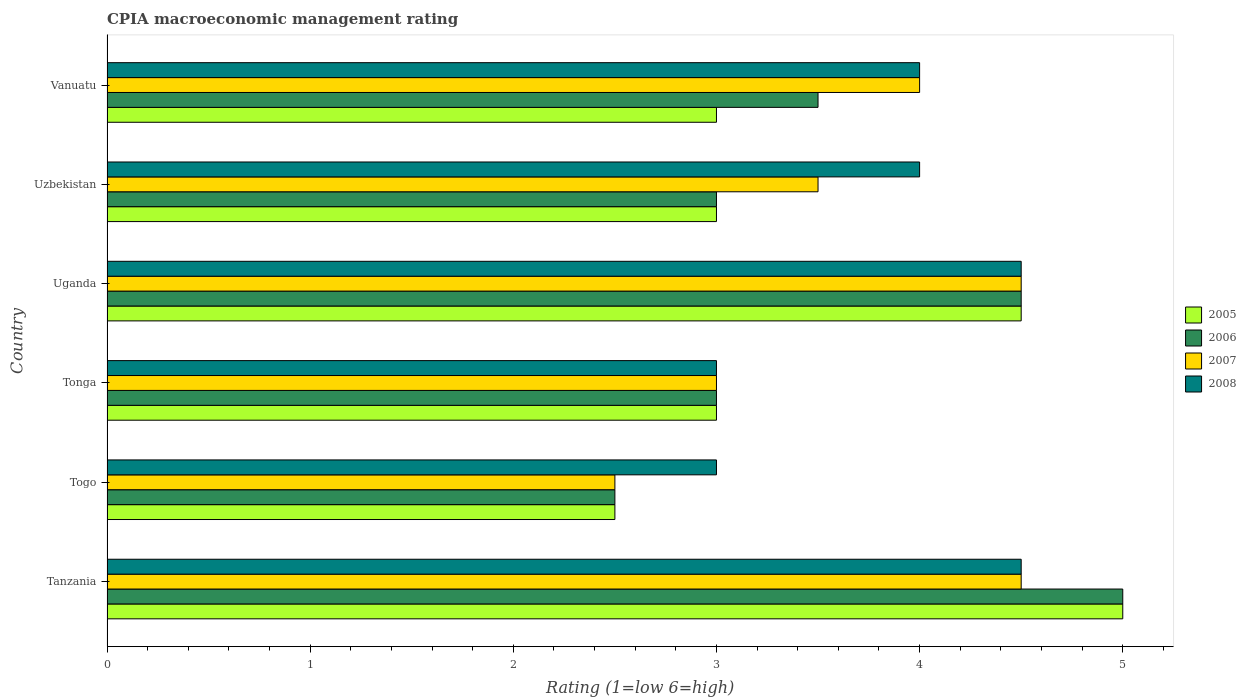How many different coloured bars are there?
Make the answer very short. 4. How many groups of bars are there?
Your response must be concise. 6. Are the number of bars per tick equal to the number of legend labels?
Offer a very short reply. Yes. How many bars are there on the 5th tick from the bottom?
Offer a very short reply. 4. What is the label of the 3rd group of bars from the top?
Ensure brevity in your answer.  Uganda. In how many cases, is the number of bars for a given country not equal to the number of legend labels?
Offer a very short reply. 0. What is the CPIA rating in 2005 in Togo?
Provide a short and direct response. 2.5. Across all countries, what is the maximum CPIA rating in 2008?
Your answer should be compact. 4.5. In which country was the CPIA rating in 2007 maximum?
Make the answer very short. Tanzania. In which country was the CPIA rating in 2008 minimum?
Make the answer very short. Togo. What is the total CPIA rating in 2008 in the graph?
Provide a succinct answer. 23. What is the difference between the CPIA rating in 2005 in Tanzania and the CPIA rating in 2006 in Tonga?
Your answer should be very brief. 2. What is the average CPIA rating in 2008 per country?
Provide a succinct answer. 3.83. What is the difference between the CPIA rating in 2007 and CPIA rating in 2006 in Uzbekistan?
Provide a succinct answer. 0.5. In how many countries, is the CPIA rating in 2007 greater than 0.4 ?
Give a very brief answer. 6. What is the ratio of the CPIA rating in 2005 in Uganda to that in Uzbekistan?
Your answer should be compact. 1.5. Is the difference between the CPIA rating in 2007 in Togo and Vanuatu greater than the difference between the CPIA rating in 2006 in Togo and Vanuatu?
Your response must be concise. No. What is the difference between the highest and the second highest CPIA rating in 2005?
Ensure brevity in your answer.  0.5. In how many countries, is the CPIA rating in 2008 greater than the average CPIA rating in 2008 taken over all countries?
Offer a very short reply. 4. Is it the case that in every country, the sum of the CPIA rating in 2007 and CPIA rating in 2008 is greater than the sum of CPIA rating in 2005 and CPIA rating in 2006?
Your response must be concise. No. What does the 4th bar from the bottom in Tanzania represents?
Your answer should be very brief. 2008. Is it the case that in every country, the sum of the CPIA rating in 2005 and CPIA rating in 2006 is greater than the CPIA rating in 2007?
Your answer should be compact. Yes. What is the difference between two consecutive major ticks on the X-axis?
Your answer should be very brief. 1. Are the values on the major ticks of X-axis written in scientific E-notation?
Give a very brief answer. No. Does the graph contain any zero values?
Keep it short and to the point. No. Does the graph contain grids?
Ensure brevity in your answer.  No. What is the title of the graph?
Provide a succinct answer. CPIA macroeconomic management rating. Does "2007" appear as one of the legend labels in the graph?
Ensure brevity in your answer.  Yes. What is the label or title of the Y-axis?
Provide a succinct answer. Country. What is the Rating (1=low 6=high) of 2005 in Togo?
Offer a very short reply. 2.5. What is the Rating (1=low 6=high) of 2006 in Togo?
Your answer should be very brief. 2.5. What is the Rating (1=low 6=high) of 2007 in Togo?
Give a very brief answer. 2.5. What is the Rating (1=low 6=high) of 2008 in Togo?
Keep it short and to the point. 3. What is the Rating (1=low 6=high) of 2005 in Tonga?
Offer a terse response. 3. What is the Rating (1=low 6=high) of 2006 in Tonga?
Give a very brief answer. 3. What is the Rating (1=low 6=high) in 2008 in Tonga?
Provide a succinct answer. 3. What is the Rating (1=low 6=high) of 2007 in Uganda?
Offer a very short reply. 4.5. What is the Rating (1=low 6=high) of 2008 in Uganda?
Give a very brief answer. 4.5. What is the Rating (1=low 6=high) in 2005 in Vanuatu?
Provide a succinct answer. 3. What is the Rating (1=low 6=high) in 2006 in Vanuatu?
Ensure brevity in your answer.  3.5. Across all countries, what is the maximum Rating (1=low 6=high) of 2006?
Give a very brief answer. 5. Across all countries, what is the maximum Rating (1=low 6=high) of 2007?
Ensure brevity in your answer.  4.5. Across all countries, what is the maximum Rating (1=low 6=high) in 2008?
Provide a short and direct response. 4.5. Across all countries, what is the minimum Rating (1=low 6=high) in 2005?
Your answer should be compact. 2.5. Across all countries, what is the minimum Rating (1=low 6=high) in 2006?
Your answer should be compact. 2.5. What is the total Rating (1=low 6=high) in 2006 in the graph?
Provide a succinct answer. 21.5. What is the total Rating (1=low 6=high) of 2008 in the graph?
Your answer should be compact. 23. What is the difference between the Rating (1=low 6=high) in 2006 in Tanzania and that in Togo?
Your response must be concise. 2.5. What is the difference between the Rating (1=low 6=high) in 2007 in Tanzania and that in Togo?
Provide a short and direct response. 2. What is the difference between the Rating (1=low 6=high) of 2008 in Tanzania and that in Togo?
Your answer should be very brief. 1.5. What is the difference between the Rating (1=low 6=high) in 2005 in Tanzania and that in Tonga?
Offer a very short reply. 2. What is the difference between the Rating (1=low 6=high) in 2006 in Tanzania and that in Uganda?
Keep it short and to the point. 0.5. What is the difference between the Rating (1=low 6=high) of 2008 in Tanzania and that in Uganda?
Ensure brevity in your answer.  0. What is the difference between the Rating (1=low 6=high) in 2008 in Tanzania and that in Uzbekistan?
Ensure brevity in your answer.  0.5. What is the difference between the Rating (1=low 6=high) of 2008 in Tanzania and that in Vanuatu?
Keep it short and to the point. 0.5. What is the difference between the Rating (1=low 6=high) of 2006 in Togo and that in Tonga?
Offer a terse response. -0.5. What is the difference between the Rating (1=low 6=high) of 2006 in Togo and that in Uganda?
Provide a short and direct response. -2. What is the difference between the Rating (1=low 6=high) in 2008 in Togo and that in Uganda?
Your answer should be compact. -1.5. What is the difference between the Rating (1=low 6=high) in 2006 in Togo and that in Uzbekistan?
Offer a very short reply. -0.5. What is the difference between the Rating (1=low 6=high) in 2007 in Togo and that in Uzbekistan?
Provide a short and direct response. -1. What is the difference between the Rating (1=low 6=high) in 2008 in Togo and that in Uzbekistan?
Your response must be concise. -1. What is the difference between the Rating (1=low 6=high) of 2006 in Togo and that in Vanuatu?
Provide a succinct answer. -1. What is the difference between the Rating (1=low 6=high) in 2005 in Tonga and that in Uganda?
Keep it short and to the point. -1.5. What is the difference between the Rating (1=low 6=high) of 2006 in Tonga and that in Uganda?
Provide a succinct answer. -1.5. What is the difference between the Rating (1=low 6=high) of 2007 in Tonga and that in Uganda?
Keep it short and to the point. -1.5. What is the difference between the Rating (1=low 6=high) in 2005 in Tonga and that in Uzbekistan?
Ensure brevity in your answer.  0. What is the difference between the Rating (1=low 6=high) in 2006 in Tonga and that in Uzbekistan?
Provide a succinct answer. 0. What is the difference between the Rating (1=low 6=high) of 2005 in Tonga and that in Vanuatu?
Provide a succinct answer. 0. What is the difference between the Rating (1=low 6=high) in 2006 in Tonga and that in Vanuatu?
Provide a short and direct response. -0.5. What is the difference between the Rating (1=low 6=high) of 2007 in Tonga and that in Vanuatu?
Provide a succinct answer. -1. What is the difference between the Rating (1=low 6=high) of 2005 in Uganda and that in Uzbekistan?
Your response must be concise. 1.5. What is the difference between the Rating (1=low 6=high) in 2005 in Uganda and that in Vanuatu?
Your answer should be very brief. 1.5. What is the difference between the Rating (1=low 6=high) in 2007 in Uganda and that in Vanuatu?
Your answer should be very brief. 0.5. What is the difference between the Rating (1=low 6=high) of 2008 in Uganda and that in Vanuatu?
Offer a very short reply. 0.5. What is the difference between the Rating (1=low 6=high) of 2006 in Uzbekistan and that in Vanuatu?
Give a very brief answer. -0.5. What is the difference between the Rating (1=low 6=high) in 2007 in Uzbekistan and that in Vanuatu?
Offer a terse response. -0.5. What is the difference between the Rating (1=low 6=high) of 2008 in Uzbekistan and that in Vanuatu?
Keep it short and to the point. 0. What is the difference between the Rating (1=low 6=high) of 2005 in Tanzania and the Rating (1=low 6=high) of 2007 in Tonga?
Make the answer very short. 2. What is the difference between the Rating (1=low 6=high) in 2006 in Tanzania and the Rating (1=low 6=high) in 2007 in Tonga?
Provide a succinct answer. 2. What is the difference between the Rating (1=low 6=high) of 2007 in Tanzania and the Rating (1=low 6=high) of 2008 in Tonga?
Offer a very short reply. 1.5. What is the difference between the Rating (1=low 6=high) of 2005 in Tanzania and the Rating (1=low 6=high) of 2006 in Uganda?
Your answer should be very brief. 0.5. What is the difference between the Rating (1=low 6=high) in 2006 in Tanzania and the Rating (1=low 6=high) in 2007 in Uganda?
Your answer should be very brief. 0.5. What is the difference between the Rating (1=low 6=high) in 2006 in Tanzania and the Rating (1=low 6=high) in 2008 in Uganda?
Offer a very short reply. 0.5. What is the difference between the Rating (1=low 6=high) in 2005 in Tanzania and the Rating (1=low 6=high) in 2006 in Uzbekistan?
Give a very brief answer. 2. What is the difference between the Rating (1=low 6=high) of 2006 in Tanzania and the Rating (1=low 6=high) of 2008 in Uzbekistan?
Your answer should be very brief. 1. What is the difference between the Rating (1=low 6=high) of 2007 in Tanzania and the Rating (1=low 6=high) of 2008 in Uzbekistan?
Your answer should be very brief. 0.5. What is the difference between the Rating (1=low 6=high) of 2005 in Tanzania and the Rating (1=low 6=high) of 2007 in Vanuatu?
Keep it short and to the point. 1. What is the difference between the Rating (1=low 6=high) of 2005 in Togo and the Rating (1=low 6=high) of 2006 in Tonga?
Your response must be concise. -0.5. What is the difference between the Rating (1=low 6=high) in 2005 in Togo and the Rating (1=low 6=high) in 2008 in Tonga?
Provide a succinct answer. -0.5. What is the difference between the Rating (1=low 6=high) in 2006 in Togo and the Rating (1=low 6=high) in 2007 in Tonga?
Your answer should be very brief. -0.5. What is the difference between the Rating (1=low 6=high) of 2007 in Togo and the Rating (1=low 6=high) of 2008 in Tonga?
Ensure brevity in your answer.  -0.5. What is the difference between the Rating (1=low 6=high) in 2005 in Togo and the Rating (1=low 6=high) in 2008 in Uganda?
Provide a short and direct response. -2. What is the difference between the Rating (1=low 6=high) in 2006 in Togo and the Rating (1=low 6=high) in 2008 in Uganda?
Give a very brief answer. -2. What is the difference between the Rating (1=low 6=high) in 2007 in Togo and the Rating (1=low 6=high) in 2008 in Uganda?
Offer a terse response. -2. What is the difference between the Rating (1=low 6=high) of 2005 in Togo and the Rating (1=low 6=high) of 2006 in Uzbekistan?
Keep it short and to the point. -0.5. What is the difference between the Rating (1=low 6=high) of 2005 in Togo and the Rating (1=low 6=high) of 2007 in Uzbekistan?
Offer a terse response. -1. What is the difference between the Rating (1=low 6=high) in 2005 in Togo and the Rating (1=low 6=high) in 2008 in Uzbekistan?
Provide a short and direct response. -1.5. What is the difference between the Rating (1=low 6=high) of 2006 in Togo and the Rating (1=low 6=high) of 2007 in Uzbekistan?
Your answer should be compact. -1. What is the difference between the Rating (1=low 6=high) in 2006 in Togo and the Rating (1=low 6=high) in 2008 in Uzbekistan?
Offer a terse response. -1.5. What is the difference between the Rating (1=low 6=high) of 2005 in Togo and the Rating (1=low 6=high) of 2006 in Vanuatu?
Your response must be concise. -1. What is the difference between the Rating (1=low 6=high) of 2005 in Togo and the Rating (1=low 6=high) of 2007 in Vanuatu?
Your response must be concise. -1.5. What is the difference between the Rating (1=low 6=high) of 2006 in Togo and the Rating (1=low 6=high) of 2008 in Vanuatu?
Keep it short and to the point. -1.5. What is the difference between the Rating (1=low 6=high) in 2007 in Togo and the Rating (1=low 6=high) in 2008 in Vanuatu?
Offer a very short reply. -1.5. What is the difference between the Rating (1=low 6=high) in 2005 in Tonga and the Rating (1=low 6=high) in 2007 in Uganda?
Keep it short and to the point. -1.5. What is the difference between the Rating (1=low 6=high) of 2006 in Tonga and the Rating (1=low 6=high) of 2007 in Uganda?
Your answer should be compact. -1.5. What is the difference between the Rating (1=low 6=high) of 2007 in Tonga and the Rating (1=low 6=high) of 2008 in Uganda?
Offer a very short reply. -1.5. What is the difference between the Rating (1=low 6=high) in 2005 in Tonga and the Rating (1=low 6=high) in 2007 in Uzbekistan?
Make the answer very short. -0.5. What is the difference between the Rating (1=low 6=high) in 2005 in Tonga and the Rating (1=low 6=high) in 2008 in Uzbekistan?
Make the answer very short. -1. What is the difference between the Rating (1=low 6=high) of 2006 in Tonga and the Rating (1=low 6=high) of 2008 in Uzbekistan?
Offer a terse response. -1. What is the difference between the Rating (1=low 6=high) of 2005 in Tonga and the Rating (1=low 6=high) of 2007 in Vanuatu?
Your response must be concise. -1. What is the difference between the Rating (1=low 6=high) in 2005 in Tonga and the Rating (1=low 6=high) in 2008 in Vanuatu?
Offer a terse response. -1. What is the difference between the Rating (1=low 6=high) in 2006 in Tonga and the Rating (1=low 6=high) in 2007 in Vanuatu?
Ensure brevity in your answer.  -1. What is the difference between the Rating (1=low 6=high) in 2006 in Tonga and the Rating (1=low 6=high) in 2008 in Vanuatu?
Offer a terse response. -1. What is the difference between the Rating (1=low 6=high) of 2007 in Tonga and the Rating (1=low 6=high) of 2008 in Vanuatu?
Keep it short and to the point. -1. What is the difference between the Rating (1=low 6=high) of 2005 in Uganda and the Rating (1=low 6=high) of 2007 in Uzbekistan?
Make the answer very short. 1. What is the difference between the Rating (1=low 6=high) of 2005 in Uganda and the Rating (1=low 6=high) of 2008 in Uzbekistan?
Offer a terse response. 0.5. What is the difference between the Rating (1=low 6=high) of 2007 in Uganda and the Rating (1=low 6=high) of 2008 in Uzbekistan?
Give a very brief answer. 0.5. What is the difference between the Rating (1=low 6=high) of 2005 in Uganda and the Rating (1=low 6=high) of 2006 in Vanuatu?
Offer a terse response. 1. What is the difference between the Rating (1=low 6=high) in 2005 in Uganda and the Rating (1=low 6=high) in 2007 in Vanuatu?
Offer a very short reply. 0.5. What is the difference between the Rating (1=low 6=high) of 2006 in Uganda and the Rating (1=low 6=high) of 2007 in Vanuatu?
Your answer should be very brief. 0.5. What is the difference between the Rating (1=low 6=high) in 2005 in Uzbekistan and the Rating (1=low 6=high) in 2006 in Vanuatu?
Ensure brevity in your answer.  -0.5. What is the difference between the Rating (1=low 6=high) of 2005 in Uzbekistan and the Rating (1=low 6=high) of 2007 in Vanuatu?
Provide a short and direct response. -1. What is the difference between the Rating (1=low 6=high) of 2006 in Uzbekistan and the Rating (1=low 6=high) of 2007 in Vanuatu?
Keep it short and to the point. -1. What is the difference between the Rating (1=low 6=high) in 2007 in Uzbekistan and the Rating (1=low 6=high) in 2008 in Vanuatu?
Make the answer very short. -0.5. What is the average Rating (1=low 6=high) in 2006 per country?
Ensure brevity in your answer.  3.58. What is the average Rating (1=low 6=high) of 2007 per country?
Your response must be concise. 3.67. What is the average Rating (1=low 6=high) in 2008 per country?
Ensure brevity in your answer.  3.83. What is the difference between the Rating (1=low 6=high) in 2005 and Rating (1=low 6=high) in 2006 in Tanzania?
Make the answer very short. 0. What is the difference between the Rating (1=low 6=high) of 2005 and Rating (1=low 6=high) of 2007 in Tanzania?
Make the answer very short. 0.5. What is the difference between the Rating (1=low 6=high) in 2005 and Rating (1=low 6=high) in 2008 in Tanzania?
Give a very brief answer. 0.5. What is the difference between the Rating (1=low 6=high) of 2006 and Rating (1=low 6=high) of 2007 in Tanzania?
Ensure brevity in your answer.  0.5. What is the difference between the Rating (1=low 6=high) of 2007 and Rating (1=low 6=high) of 2008 in Tanzania?
Offer a very short reply. 0. What is the difference between the Rating (1=low 6=high) of 2005 and Rating (1=low 6=high) of 2006 in Togo?
Your answer should be compact. 0. What is the difference between the Rating (1=low 6=high) in 2007 and Rating (1=low 6=high) in 2008 in Togo?
Keep it short and to the point. -0.5. What is the difference between the Rating (1=low 6=high) of 2005 and Rating (1=low 6=high) of 2007 in Tonga?
Ensure brevity in your answer.  0. What is the difference between the Rating (1=low 6=high) in 2005 and Rating (1=low 6=high) in 2008 in Tonga?
Provide a succinct answer. 0. What is the difference between the Rating (1=low 6=high) of 2005 and Rating (1=low 6=high) of 2006 in Uganda?
Keep it short and to the point. 0. What is the difference between the Rating (1=low 6=high) in 2006 and Rating (1=low 6=high) in 2007 in Uganda?
Keep it short and to the point. 0. What is the difference between the Rating (1=low 6=high) of 2005 and Rating (1=low 6=high) of 2007 in Uzbekistan?
Keep it short and to the point. -0.5. What is the difference between the Rating (1=low 6=high) of 2007 and Rating (1=low 6=high) of 2008 in Uzbekistan?
Provide a succinct answer. -0.5. What is the difference between the Rating (1=low 6=high) of 2005 and Rating (1=low 6=high) of 2006 in Vanuatu?
Your answer should be compact. -0.5. What is the difference between the Rating (1=low 6=high) of 2005 and Rating (1=low 6=high) of 2007 in Vanuatu?
Make the answer very short. -1. What is the ratio of the Rating (1=low 6=high) in 2005 in Tanzania to that in Togo?
Provide a short and direct response. 2. What is the ratio of the Rating (1=low 6=high) in 2006 in Tanzania to that in Togo?
Ensure brevity in your answer.  2. What is the ratio of the Rating (1=low 6=high) of 2007 in Tanzania to that in Togo?
Offer a very short reply. 1.8. What is the ratio of the Rating (1=low 6=high) of 2008 in Tanzania to that in Tonga?
Provide a succinct answer. 1.5. What is the ratio of the Rating (1=low 6=high) in 2007 in Tanzania to that in Uganda?
Offer a very short reply. 1. What is the ratio of the Rating (1=low 6=high) in 2008 in Tanzania to that in Uganda?
Your response must be concise. 1. What is the ratio of the Rating (1=low 6=high) in 2005 in Tanzania to that in Uzbekistan?
Your answer should be very brief. 1.67. What is the ratio of the Rating (1=low 6=high) in 2006 in Tanzania to that in Uzbekistan?
Your answer should be very brief. 1.67. What is the ratio of the Rating (1=low 6=high) of 2006 in Tanzania to that in Vanuatu?
Provide a short and direct response. 1.43. What is the ratio of the Rating (1=low 6=high) of 2007 in Tanzania to that in Vanuatu?
Offer a very short reply. 1.12. What is the ratio of the Rating (1=low 6=high) in 2005 in Togo to that in Tonga?
Keep it short and to the point. 0.83. What is the ratio of the Rating (1=low 6=high) in 2006 in Togo to that in Tonga?
Your answer should be compact. 0.83. What is the ratio of the Rating (1=low 6=high) of 2008 in Togo to that in Tonga?
Give a very brief answer. 1. What is the ratio of the Rating (1=low 6=high) of 2005 in Togo to that in Uganda?
Your answer should be very brief. 0.56. What is the ratio of the Rating (1=low 6=high) in 2006 in Togo to that in Uganda?
Ensure brevity in your answer.  0.56. What is the ratio of the Rating (1=low 6=high) in 2007 in Togo to that in Uganda?
Offer a terse response. 0.56. What is the ratio of the Rating (1=low 6=high) of 2008 in Togo to that in Uganda?
Provide a short and direct response. 0.67. What is the ratio of the Rating (1=low 6=high) of 2005 in Togo to that in Uzbekistan?
Your answer should be very brief. 0.83. What is the ratio of the Rating (1=low 6=high) in 2007 in Togo to that in Uzbekistan?
Make the answer very short. 0.71. What is the ratio of the Rating (1=low 6=high) in 2005 in Togo to that in Vanuatu?
Make the answer very short. 0.83. What is the ratio of the Rating (1=low 6=high) in 2006 in Togo to that in Vanuatu?
Keep it short and to the point. 0.71. What is the ratio of the Rating (1=low 6=high) of 2007 in Togo to that in Vanuatu?
Provide a succinct answer. 0.62. What is the ratio of the Rating (1=low 6=high) in 2006 in Tonga to that in Uganda?
Make the answer very short. 0.67. What is the ratio of the Rating (1=low 6=high) of 2008 in Tonga to that in Uganda?
Make the answer very short. 0.67. What is the ratio of the Rating (1=low 6=high) of 2005 in Tonga to that in Uzbekistan?
Your answer should be very brief. 1. What is the ratio of the Rating (1=low 6=high) in 2007 in Tonga to that in Uzbekistan?
Provide a succinct answer. 0.86. What is the ratio of the Rating (1=low 6=high) in 2007 in Tonga to that in Vanuatu?
Make the answer very short. 0.75. What is the ratio of the Rating (1=low 6=high) of 2006 in Uganda to that in Uzbekistan?
Provide a short and direct response. 1.5. What is the ratio of the Rating (1=low 6=high) of 2007 in Uganda to that in Uzbekistan?
Your answer should be compact. 1.29. What is the ratio of the Rating (1=low 6=high) in 2008 in Uganda to that in Uzbekistan?
Offer a terse response. 1.12. What is the ratio of the Rating (1=low 6=high) in 2008 in Uganda to that in Vanuatu?
Your answer should be compact. 1.12. What is the difference between the highest and the second highest Rating (1=low 6=high) of 2006?
Offer a very short reply. 0.5. What is the difference between the highest and the second highest Rating (1=low 6=high) in 2007?
Your answer should be compact. 0. What is the difference between the highest and the second highest Rating (1=low 6=high) in 2008?
Give a very brief answer. 0. What is the difference between the highest and the lowest Rating (1=low 6=high) in 2008?
Offer a very short reply. 1.5. 